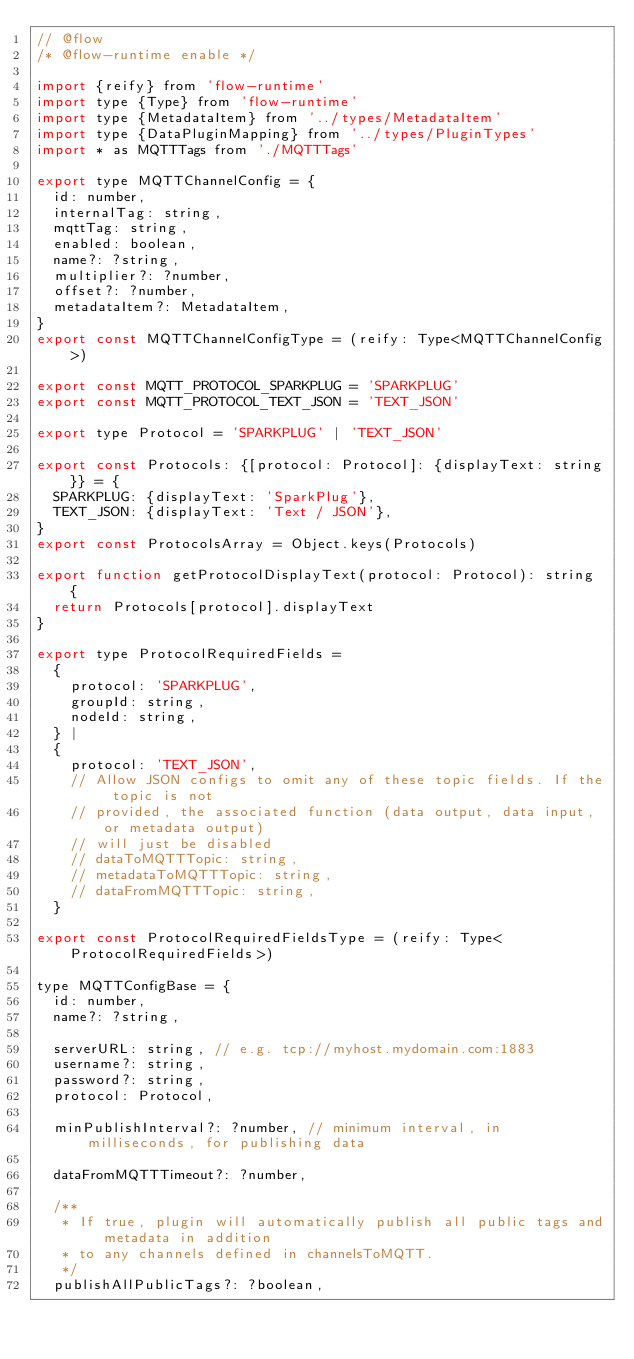<code> <loc_0><loc_0><loc_500><loc_500><_JavaScript_>// @flow
/* @flow-runtime enable */

import {reify} from 'flow-runtime'
import type {Type} from 'flow-runtime'
import type {MetadataItem} from '../types/MetadataItem'
import type {DataPluginMapping} from '../types/PluginTypes'
import * as MQTTTags from './MQTTTags'

export type MQTTChannelConfig = {
  id: number,
  internalTag: string,
  mqttTag: string,
  enabled: boolean,
  name?: ?string,
  multiplier?: ?number,
  offset?: ?number,
  metadataItem?: MetadataItem,
}
export const MQTTChannelConfigType = (reify: Type<MQTTChannelConfig>)

export const MQTT_PROTOCOL_SPARKPLUG = 'SPARKPLUG'
export const MQTT_PROTOCOL_TEXT_JSON = 'TEXT_JSON'

export type Protocol = 'SPARKPLUG' | 'TEXT_JSON'

export const Protocols: {[protocol: Protocol]: {displayText: string}} = {
  SPARKPLUG: {displayText: 'SparkPlug'},
  TEXT_JSON: {displayText: 'Text / JSON'},
}
export const ProtocolsArray = Object.keys(Protocols)

export function getProtocolDisplayText(protocol: Protocol): string {
  return Protocols[protocol].displayText
}

export type ProtocolRequiredFields =
  {
    protocol: 'SPARKPLUG',
    groupId: string,
    nodeId: string,
  } |
  {
    protocol: 'TEXT_JSON',
    // Allow JSON configs to omit any of these topic fields. If the topic is not
    // provided, the associated function (data output, data input, or metadata output)
    // will just be disabled
    // dataToMQTTTopic: string,
    // metadataToMQTTTopic: string,
    // dataFromMQTTTopic: string,
  }

export const ProtocolRequiredFieldsType = (reify: Type<ProtocolRequiredFields>)

type MQTTConfigBase = {
  id: number,
  name?: ?string,

  serverURL: string, // e.g. tcp://myhost.mydomain.com:1883
  username?: string,
  password?: string,
  protocol: Protocol,

  minPublishInterval?: ?number, // minimum interval, in milliseconds, for publishing data

  dataFromMQTTTimeout?: ?number,

  /**
   * If true, plugin will automatically publish all public tags and metadata in addition
   * to any channels defined in channelsToMQTT.
   */
  publishAllPublicTags?: ?boolean,</code> 